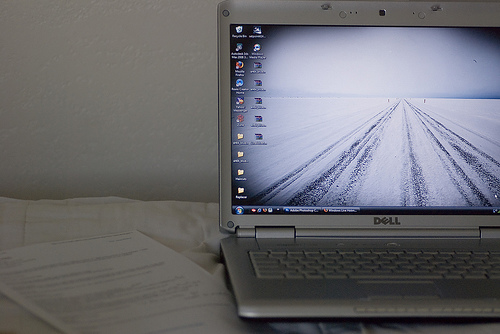<image>
Can you confirm if the paper is under the computer? Yes. The paper is positioned underneath the computer, with the computer above it in the vertical space. 